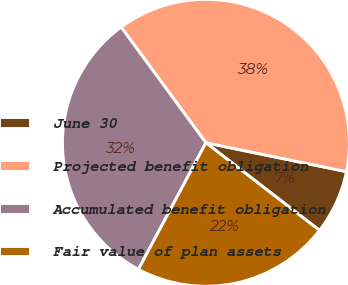<chart> <loc_0><loc_0><loc_500><loc_500><pie_chart><fcel>June 30<fcel>Projected benefit obligation<fcel>Accumulated benefit obligation<fcel>Fair value of plan assets<nl><fcel>7.23%<fcel>38.29%<fcel>32.14%<fcel>22.34%<nl></chart> 